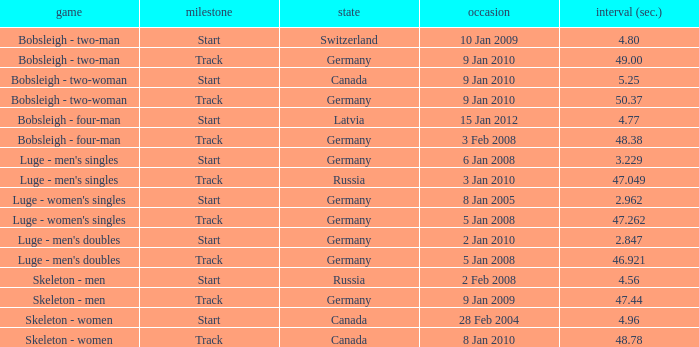Which nation had a time of 48.38? Germany. 